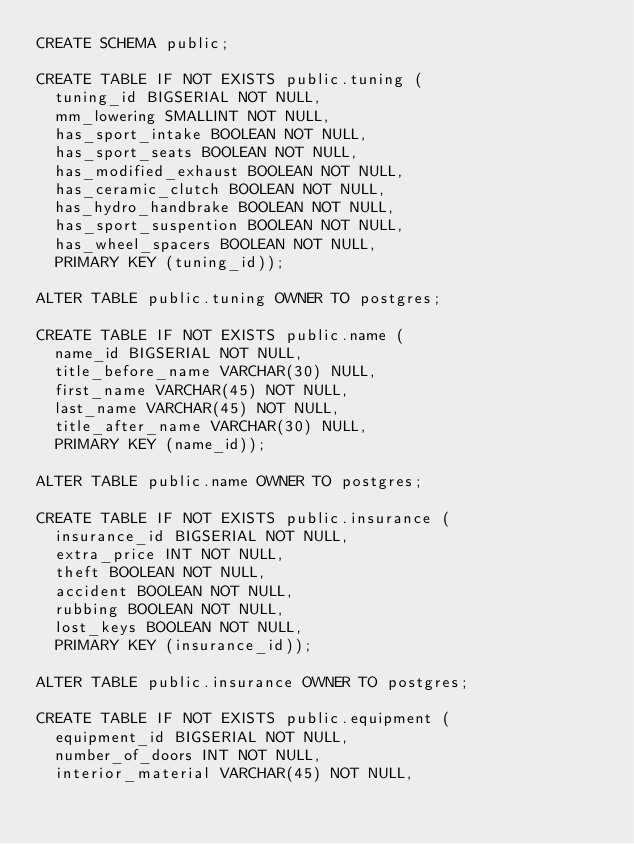Convert code to text. <code><loc_0><loc_0><loc_500><loc_500><_SQL_>CREATE SCHEMA public;

CREATE TABLE IF NOT EXISTS public.tuning (
  tuning_id BIGSERIAL NOT NULL,
  mm_lowering SMALLINT NOT NULL,
  has_sport_intake BOOLEAN NOT NULL,
  has_sport_seats BOOLEAN NOT NULL,
  has_modified_exhaust BOOLEAN NOT NULL,
  has_ceramic_clutch BOOLEAN NOT NULL,
  has_hydro_handbrake BOOLEAN NOT NULL,
  has_sport_suspention BOOLEAN NOT NULL,
  has_wheel_spacers BOOLEAN NOT NULL,
  PRIMARY KEY (tuning_id));
  
ALTER TABLE public.tuning OWNER TO postgres;

CREATE TABLE IF NOT EXISTS public.name (
  name_id BIGSERIAL NOT NULL,
  title_before_name VARCHAR(30) NULL,
  first_name VARCHAR(45) NOT NULL,
  last_name VARCHAR(45) NOT NULL,
  title_after_name VARCHAR(30) NULL,
  PRIMARY KEY (name_id));

ALTER TABLE public.name OWNER TO postgres;

CREATE TABLE IF NOT EXISTS public.insurance (
  insurance_id BIGSERIAL NOT NULL,
  extra_price INT NOT NULL,
  theft BOOLEAN NOT NULL,
  accident BOOLEAN NOT NULL,
  rubbing BOOLEAN NOT NULL,
  lost_keys BOOLEAN NOT NULL,
  PRIMARY KEY (insurance_id));
  
ALTER TABLE public.insurance OWNER TO postgres;

CREATE TABLE IF NOT EXISTS public.equipment (
  equipment_id BIGSERIAL NOT NULL,
  number_of_doors INT NOT NULL,
  interior_material VARCHAR(45) NOT NULL,</code> 